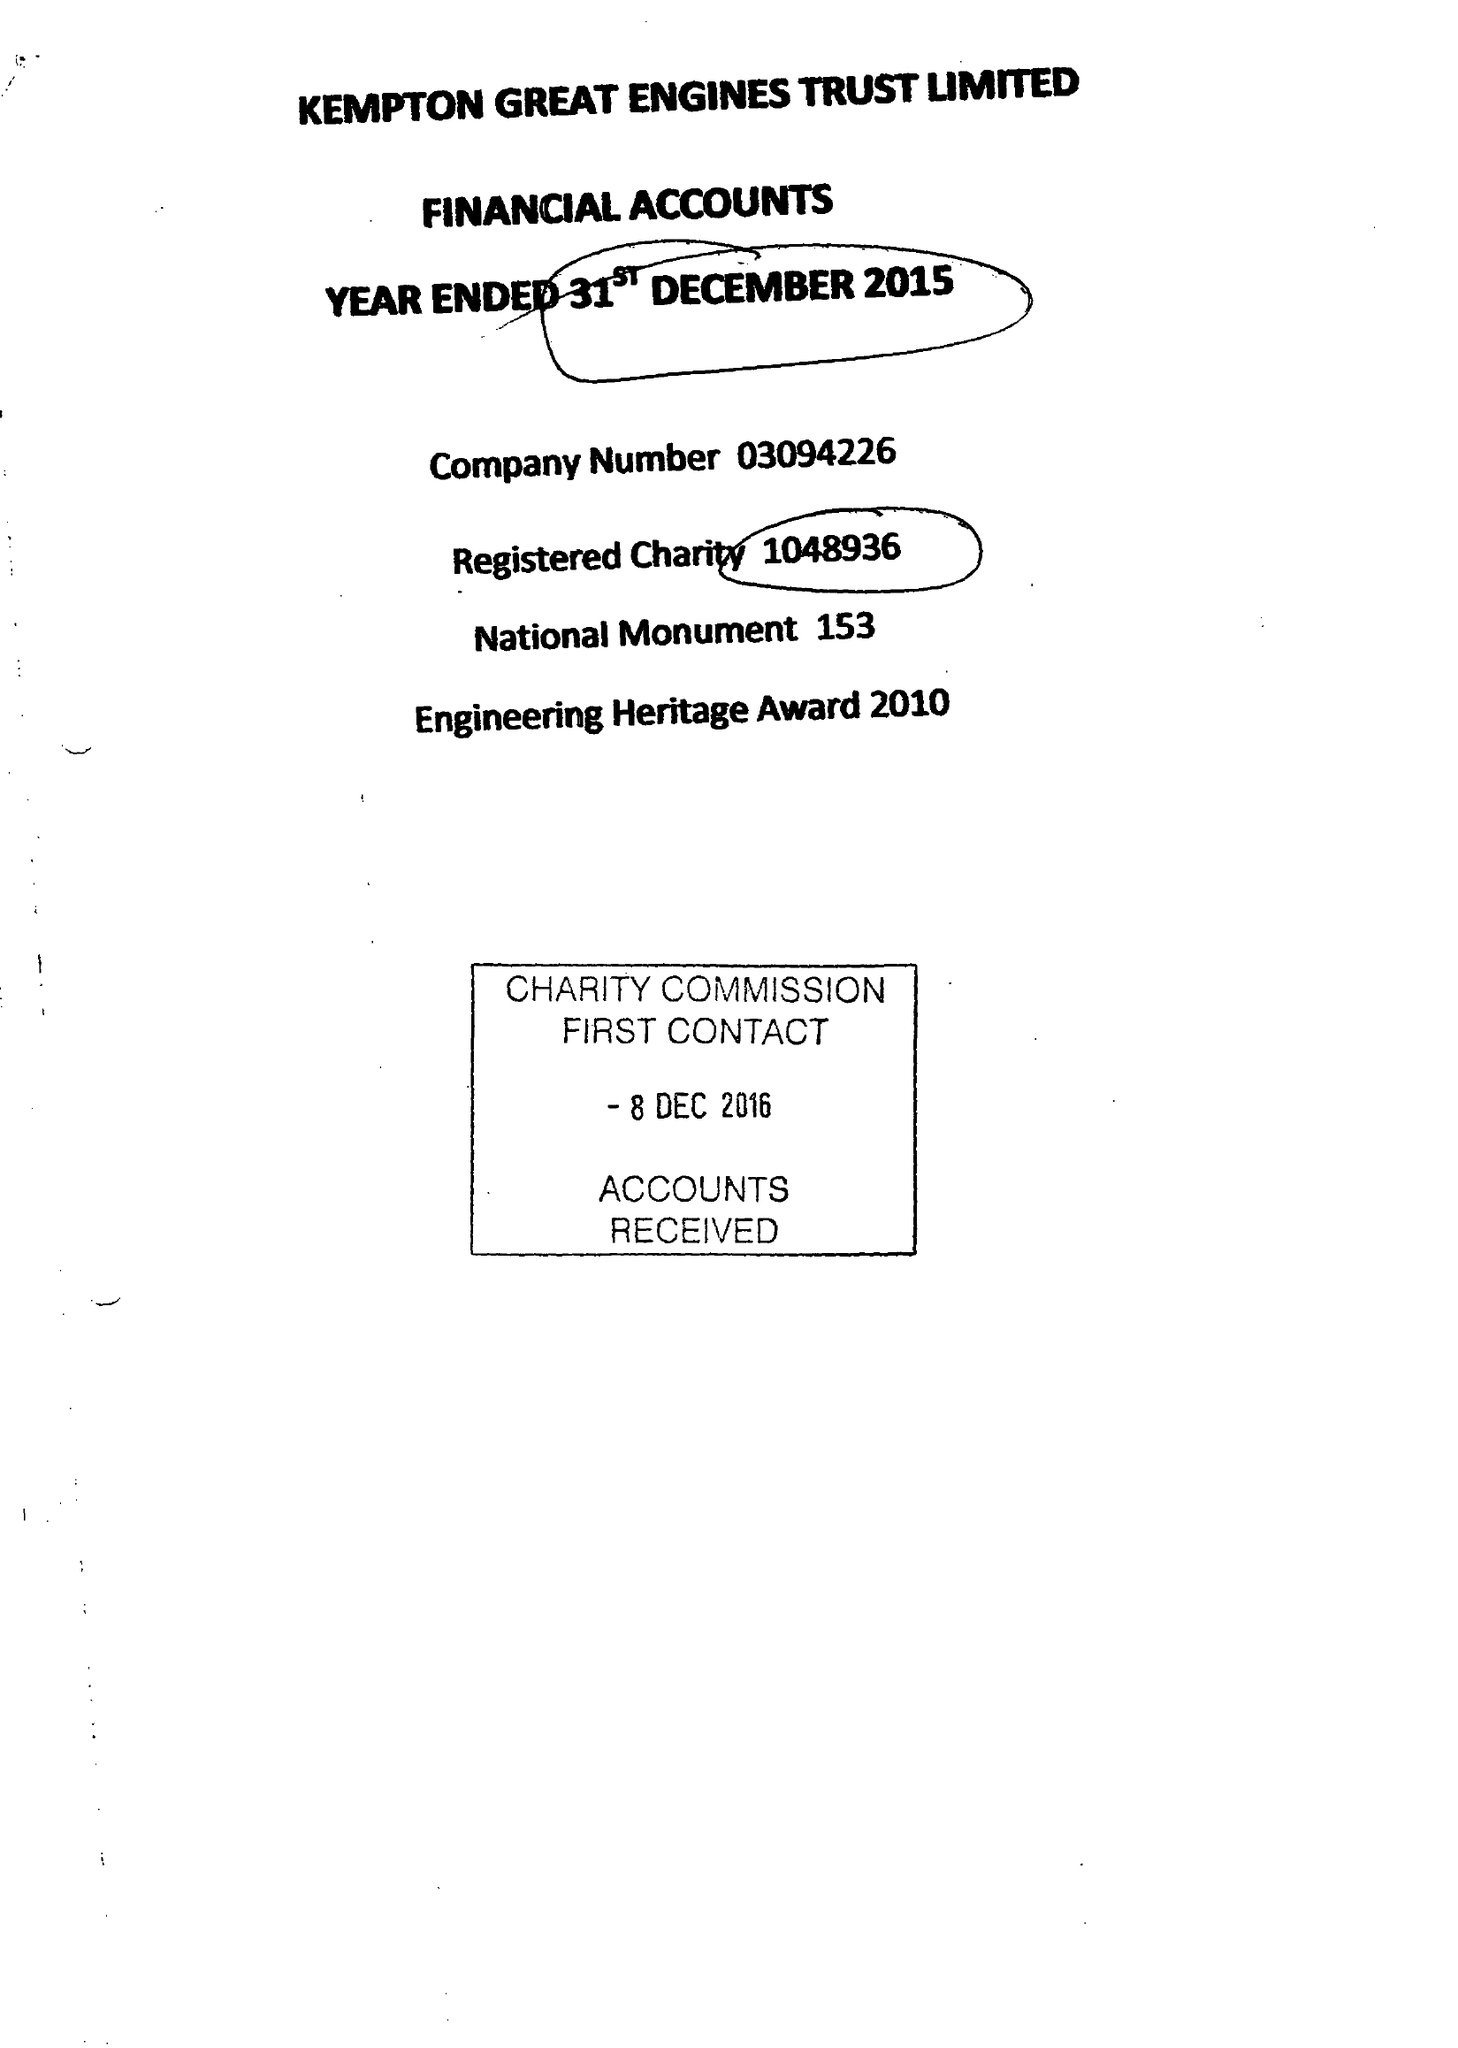What is the value for the spending_annually_in_british_pounds?
Answer the question using a single word or phrase. 46821.00 